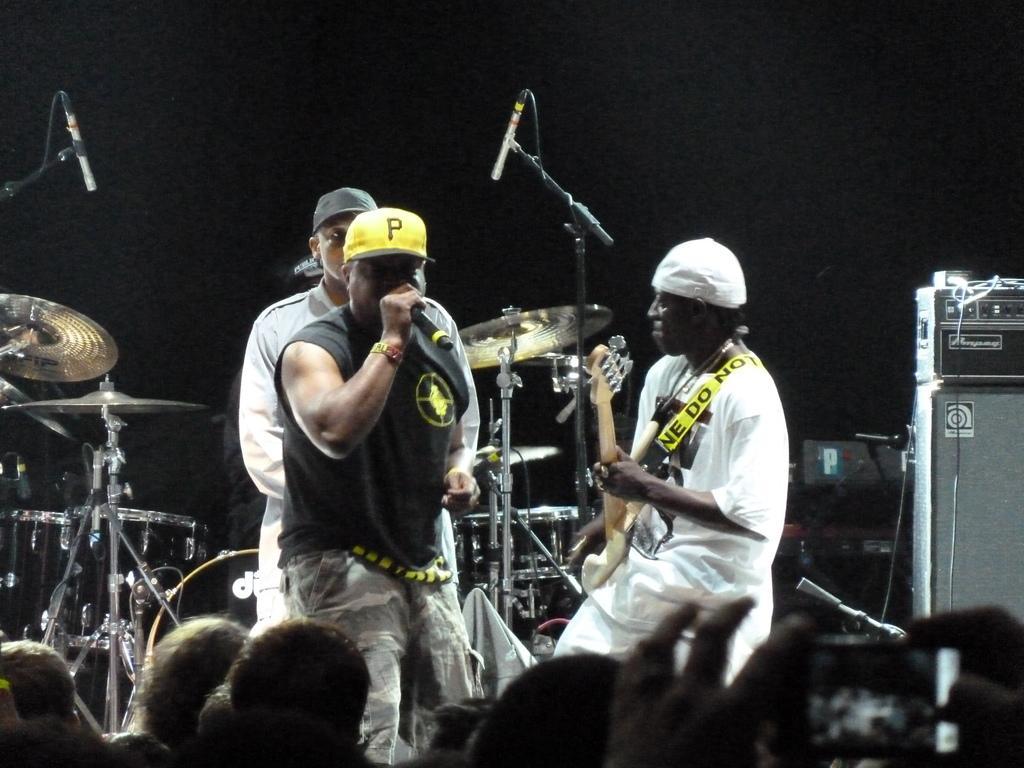Could you give a brief overview of what you see in this image? In this image i can see few people standing on stage, the person on right is holding a musical instrument in his hand and the person on the left is holding a microphone. In the background i can see few musical instruments. 